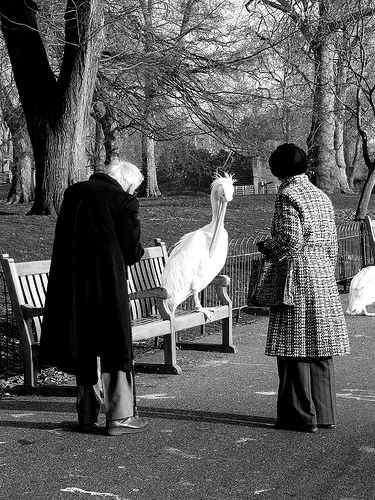Please provide the bounding box coordinate of the region this sentence describes: part of an iron gate. [0.79, 0.43, 0.86, 0.56] 